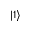Convert formula to latex. <formula><loc_0><loc_0><loc_500><loc_500>| { 1 } \rangle</formula> 